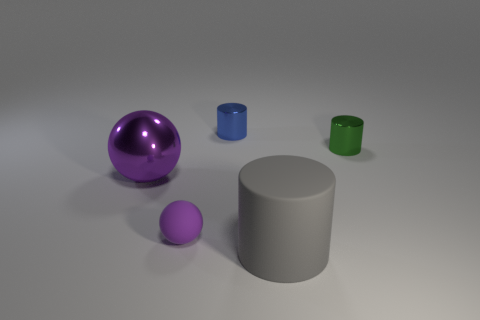Subtract all tiny metallic cylinders. How many cylinders are left? 1 Add 2 small purple objects. How many objects exist? 7 Subtract all balls. How many objects are left? 3 Subtract all large purple shiny spheres. Subtract all small green metal things. How many objects are left? 3 Add 4 green metal things. How many green metal things are left? 5 Add 1 large yellow rubber balls. How many large yellow rubber balls exist? 1 Subtract 0 gray balls. How many objects are left? 5 Subtract all purple cylinders. Subtract all purple cubes. How many cylinders are left? 3 